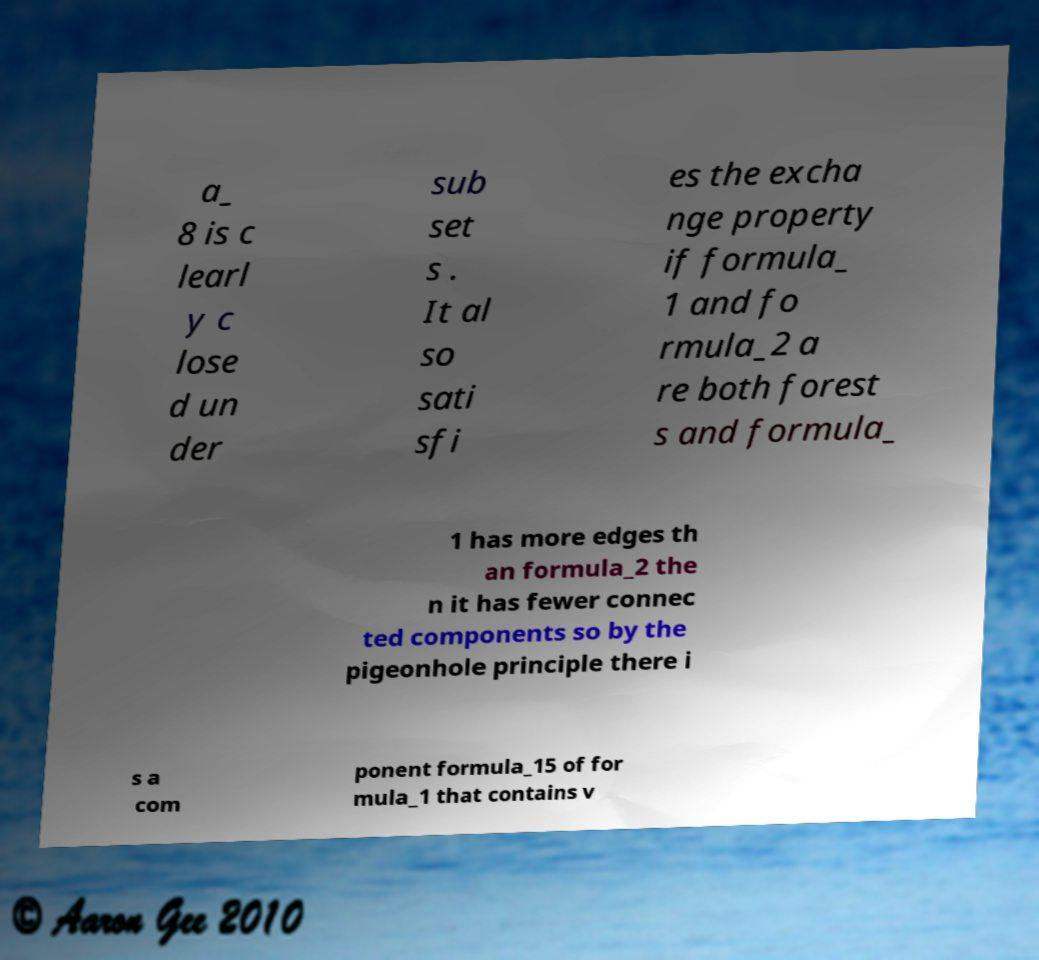Please read and relay the text visible in this image. What does it say? a_ 8 is c learl y c lose d un der sub set s . It al so sati sfi es the excha nge property if formula_ 1 and fo rmula_2 a re both forest s and formula_ 1 has more edges th an formula_2 the n it has fewer connec ted components so by the pigeonhole principle there i s a com ponent formula_15 of for mula_1 that contains v 